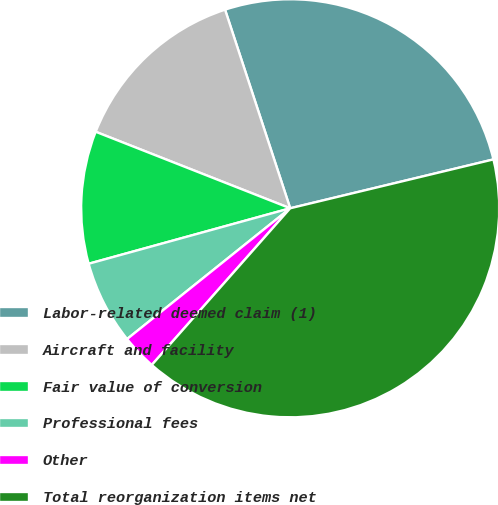<chart> <loc_0><loc_0><loc_500><loc_500><pie_chart><fcel>Labor-related deemed claim (1)<fcel>Aircraft and facility<fcel>Fair value of conversion<fcel>Professional fees<fcel>Other<fcel>Total reorganization items net<nl><fcel>26.29%<fcel>13.99%<fcel>10.24%<fcel>6.48%<fcel>2.73%<fcel>40.27%<nl></chart> 